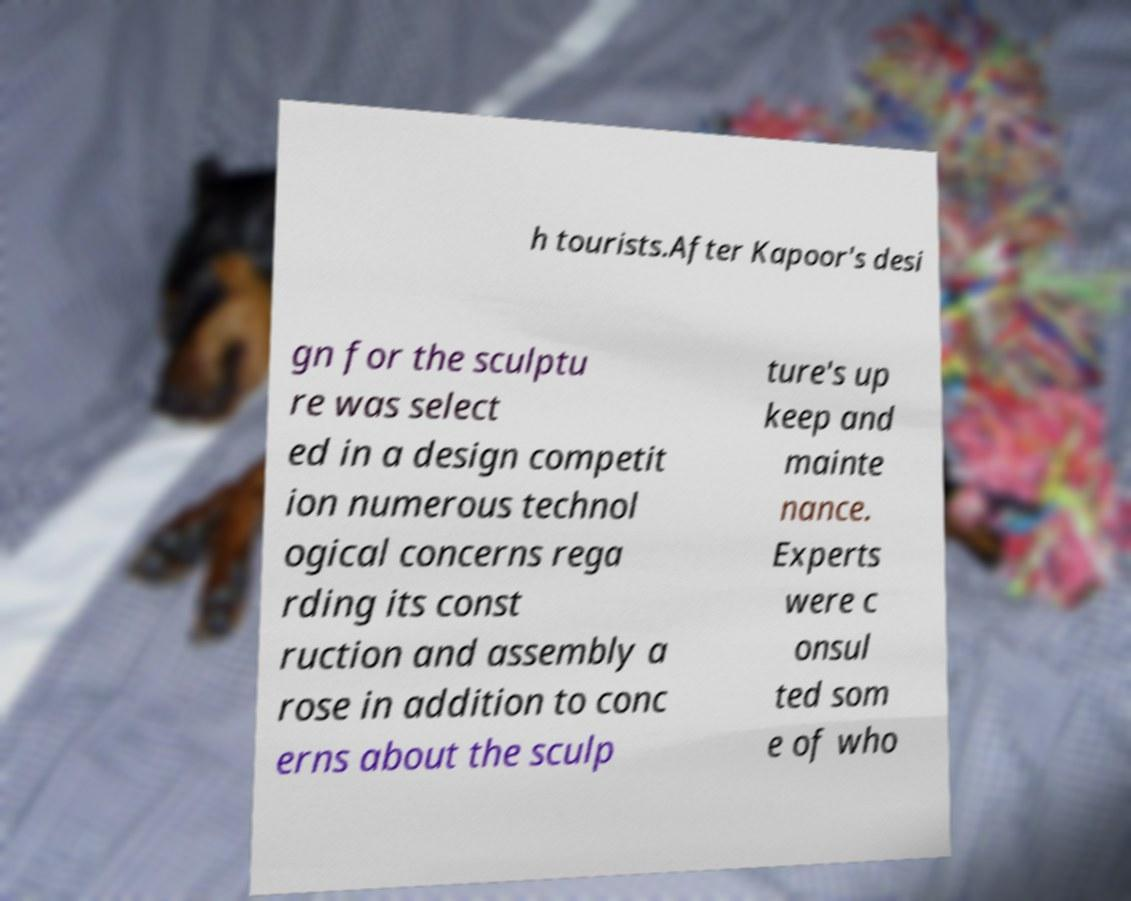Please identify and transcribe the text found in this image. h tourists.After Kapoor's desi gn for the sculptu re was select ed in a design competit ion numerous technol ogical concerns rega rding its const ruction and assembly a rose in addition to conc erns about the sculp ture's up keep and mainte nance. Experts were c onsul ted som e of who 